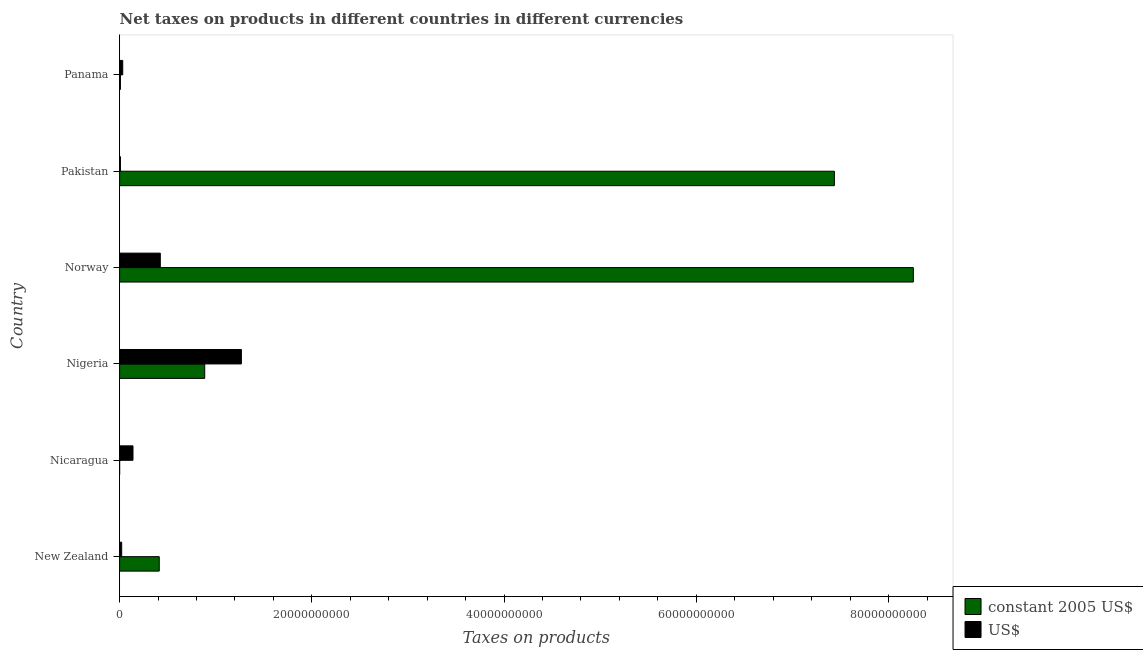Are the number of bars per tick equal to the number of legend labels?
Your response must be concise. Yes. What is the net taxes in us$ in Nicaragua?
Offer a very short reply. 1.39e+09. Across all countries, what is the maximum net taxes in us$?
Give a very brief answer. 1.27e+1. Across all countries, what is the minimum net taxes in us$?
Ensure brevity in your answer.  8.76e+07. In which country was the net taxes in us$ maximum?
Keep it short and to the point. Nigeria. In which country was the net taxes in us$ minimum?
Keep it short and to the point. Pakistan. What is the total net taxes in constant 2005 us$ in the graph?
Give a very brief answer. 1.70e+11. What is the difference between the net taxes in us$ in Nigeria and that in Panama?
Offer a terse response. 1.23e+1. What is the difference between the net taxes in us$ in Norway and the net taxes in constant 2005 us$ in Pakistan?
Provide a succinct answer. -7.01e+1. What is the average net taxes in us$ per country?
Offer a terse response. 3.16e+09. What is the difference between the net taxes in constant 2005 us$ and net taxes in us$ in Panama?
Ensure brevity in your answer.  -2.39e+08. What is the ratio of the net taxes in us$ in Nicaragua to that in Pakistan?
Make the answer very short. 15.9. Is the net taxes in constant 2005 us$ in Pakistan less than that in Panama?
Offer a terse response. No. What is the difference between the highest and the second highest net taxes in us$?
Your answer should be very brief. 8.44e+09. What is the difference between the highest and the lowest net taxes in constant 2005 us$?
Provide a short and direct response. 8.26e+1. In how many countries, is the net taxes in us$ greater than the average net taxes in us$ taken over all countries?
Keep it short and to the point. 2. What does the 1st bar from the top in Panama represents?
Your answer should be compact. US$. What does the 2nd bar from the bottom in New Zealand represents?
Your answer should be very brief. US$. What is the difference between two consecutive major ticks on the X-axis?
Provide a succinct answer. 2.00e+1. Are the values on the major ticks of X-axis written in scientific E-notation?
Provide a short and direct response. No. How many legend labels are there?
Give a very brief answer. 2. What is the title of the graph?
Give a very brief answer. Net taxes on products in different countries in different currencies. Does "State government" appear as one of the legend labels in the graph?
Offer a terse response. No. What is the label or title of the X-axis?
Your answer should be compact. Taxes on products. What is the Taxes on products of constant 2005 US$ in New Zealand?
Your response must be concise. 4.13e+09. What is the Taxes on products in US$ in New Zealand?
Offer a terse response. 2.17e+08. What is the Taxes on products in constant 2005 US$ in Nicaragua?
Ensure brevity in your answer.  5343.08. What is the Taxes on products of US$ in Nicaragua?
Provide a short and direct response. 1.39e+09. What is the Taxes on products of constant 2005 US$ in Nigeria?
Your response must be concise. 8.86e+09. What is the Taxes on products of US$ in Nigeria?
Your answer should be compact. 1.27e+1. What is the Taxes on products in constant 2005 US$ in Norway?
Your response must be concise. 8.26e+1. What is the Taxes on products in US$ in Norway?
Your answer should be compact. 4.24e+09. What is the Taxes on products of constant 2005 US$ in Pakistan?
Provide a succinct answer. 7.44e+1. What is the Taxes on products in US$ in Pakistan?
Your answer should be very brief. 8.76e+07. What is the Taxes on products of constant 2005 US$ in Panama?
Provide a short and direct response. 8.76e+07. What is the Taxes on products in US$ in Panama?
Your answer should be very brief. 3.27e+08. Across all countries, what is the maximum Taxes on products of constant 2005 US$?
Your answer should be compact. 8.26e+1. Across all countries, what is the maximum Taxes on products of US$?
Your answer should be compact. 1.27e+1. Across all countries, what is the minimum Taxes on products of constant 2005 US$?
Offer a very short reply. 5343.08. Across all countries, what is the minimum Taxes on products of US$?
Ensure brevity in your answer.  8.76e+07. What is the total Taxes on products of constant 2005 US$ in the graph?
Offer a terse response. 1.70e+11. What is the total Taxes on products of US$ in the graph?
Give a very brief answer. 1.89e+1. What is the difference between the Taxes on products of constant 2005 US$ in New Zealand and that in Nicaragua?
Give a very brief answer. 4.13e+09. What is the difference between the Taxes on products of US$ in New Zealand and that in Nicaragua?
Make the answer very short. -1.18e+09. What is the difference between the Taxes on products in constant 2005 US$ in New Zealand and that in Nigeria?
Offer a very short reply. -4.73e+09. What is the difference between the Taxes on products in US$ in New Zealand and that in Nigeria?
Make the answer very short. -1.25e+1. What is the difference between the Taxes on products of constant 2005 US$ in New Zealand and that in Norway?
Offer a terse response. -7.85e+1. What is the difference between the Taxes on products of US$ in New Zealand and that in Norway?
Give a very brief answer. -4.02e+09. What is the difference between the Taxes on products in constant 2005 US$ in New Zealand and that in Pakistan?
Your response must be concise. -7.02e+1. What is the difference between the Taxes on products of US$ in New Zealand and that in Pakistan?
Your answer should be very brief. 1.30e+08. What is the difference between the Taxes on products in constant 2005 US$ in New Zealand and that in Panama?
Give a very brief answer. 4.04e+09. What is the difference between the Taxes on products in US$ in New Zealand and that in Panama?
Keep it short and to the point. -1.09e+08. What is the difference between the Taxes on products of constant 2005 US$ in Nicaragua and that in Nigeria?
Provide a short and direct response. -8.86e+09. What is the difference between the Taxes on products of US$ in Nicaragua and that in Nigeria?
Your answer should be very brief. -1.13e+1. What is the difference between the Taxes on products of constant 2005 US$ in Nicaragua and that in Norway?
Ensure brevity in your answer.  -8.26e+1. What is the difference between the Taxes on products of US$ in Nicaragua and that in Norway?
Your answer should be compact. -2.84e+09. What is the difference between the Taxes on products in constant 2005 US$ in Nicaragua and that in Pakistan?
Offer a terse response. -7.44e+1. What is the difference between the Taxes on products of US$ in Nicaragua and that in Pakistan?
Offer a terse response. 1.31e+09. What is the difference between the Taxes on products in constant 2005 US$ in Nicaragua and that in Panama?
Your answer should be very brief. -8.76e+07. What is the difference between the Taxes on products in US$ in Nicaragua and that in Panama?
Give a very brief answer. 1.07e+09. What is the difference between the Taxes on products in constant 2005 US$ in Nigeria and that in Norway?
Offer a very short reply. -7.37e+1. What is the difference between the Taxes on products in US$ in Nigeria and that in Norway?
Keep it short and to the point. 8.44e+09. What is the difference between the Taxes on products in constant 2005 US$ in Nigeria and that in Pakistan?
Offer a terse response. -6.55e+1. What is the difference between the Taxes on products in US$ in Nigeria and that in Pakistan?
Ensure brevity in your answer.  1.26e+1. What is the difference between the Taxes on products in constant 2005 US$ in Nigeria and that in Panama?
Offer a terse response. 8.77e+09. What is the difference between the Taxes on products of US$ in Nigeria and that in Panama?
Offer a very short reply. 1.23e+1. What is the difference between the Taxes on products of constant 2005 US$ in Norway and that in Pakistan?
Provide a short and direct response. 8.21e+09. What is the difference between the Taxes on products in US$ in Norway and that in Pakistan?
Your response must be concise. 4.15e+09. What is the difference between the Taxes on products in constant 2005 US$ in Norway and that in Panama?
Your answer should be very brief. 8.25e+1. What is the difference between the Taxes on products in US$ in Norway and that in Panama?
Your answer should be compact. 3.91e+09. What is the difference between the Taxes on products of constant 2005 US$ in Pakistan and that in Panama?
Give a very brief answer. 7.43e+1. What is the difference between the Taxes on products in US$ in Pakistan and that in Panama?
Provide a short and direct response. -2.39e+08. What is the difference between the Taxes on products of constant 2005 US$ in New Zealand and the Taxes on products of US$ in Nicaragua?
Offer a very short reply. 2.73e+09. What is the difference between the Taxes on products in constant 2005 US$ in New Zealand and the Taxes on products in US$ in Nigeria?
Offer a terse response. -8.55e+09. What is the difference between the Taxes on products in constant 2005 US$ in New Zealand and the Taxes on products in US$ in Norway?
Provide a succinct answer. -1.11e+08. What is the difference between the Taxes on products of constant 2005 US$ in New Zealand and the Taxes on products of US$ in Pakistan?
Your answer should be compact. 4.04e+09. What is the difference between the Taxes on products of constant 2005 US$ in New Zealand and the Taxes on products of US$ in Panama?
Provide a short and direct response. 3.80e+09. What is the difference between the Taxes on products in constant 2005 US$ in Nicaragua and the Taxes on products in US$ in Nigeria?
Give a very brief answer. -1.27e+1. What is the difference between the Taxes on products in constant 2005 US$ in Nicaragua and the Taxes on products in US$ in Norway?
Provide a succinct answer. -4.24e+09. What is the difference between the Taxes on products of constant 2005 US$ in Nicaragua and the Taxes on products of US$ in Pakistan?
Your response must be concise. -8.76e+07. What is the difference between the Taxes on products in constant 2005 US$ in Nicaragua and the Taxes on products in US$ in Panama?
Your answer should be very brief. -3.27e+08. What is the difference between the Taxes on products of constant 2005 US$ in Nigeria and the Taxes on products of US$ in Norway?
Offer a terse response. 4.62e+09. What is the difference between the Taxes on products in constant 2005 US$ in Nigeria and the Taxes on products in US$ in Pakistan?
Offer a very short reply. 8.77e+09. What is the difference between the Taxes on products of constant 2005 US$ in Nigeria and the Taxes on products of US$ in Panama?
Ensure brevity in your answer.  8.53e+09. What is the difference between the Taxes on products of constant 2005 US$ in Norway and the Taxes on products of US$ in Pakistan?
Offer a terse response. 8.25e+1. What is the difference between the Taxes on products of constant 2005 US$ in Norway and the Taxes on products of US$ in Panama?
Your answer should be compact. 8.23e+1. What is the difference between the Taxes on products of constant 2005 US$ in Pakistan and the Taxes on products of US$ in Panama?
Ensure brevity in your answer.  7.40e+1. What is the average Taxes on products of constant 2005 US$ per country?
Your answer should be compact. 2.83e+1. What is the average Taxes on products of US$ per country?
Offer a very short reply. 3.16e+09. What is the difference between the Taxes on products in constant 2005 US$ and Taxes on products in US$ in New Zealand?
Ensure brevity in your answer.  3.91e+09. What is the difference between the Taxes on products in constant 2005 US$ and Taxes on products in US$ in Nicaragua?
Make the answer very short. -1.39e+09. What is the difference between the Taxes on products of constant 2005 US$ and Taxes on products of US$ in Nigeria?
Your answer should be compact. -3.82e+09. What is the difference between the Taxes on products in constant 2005 US$ and Taxes on products in US$ in Norway?
Provide a short and direct response. 7.83e+1. What is the difference between the Taxes on products in constant 2005 US$ and Taxes on products in US$ in Pakistan?
Provide a succinct answer. 7.43e+1. What is the difference between the Taxes on products in constant 2005 US$ and Taxes on products in US$ in Panama?
Give a very brief answer. -2.39e+08. What is the ratio of the Taxes on products of constant 2005 US$ in New Zealand to that in Nicaragua?
Your answer should be compact. 7.72e+05. What is the ratio of the Taxes on products in US$ in New Zealand to that in Nicaragua?
Offer a very short reply. 0.16. What is the ratio of the Taxes on products in constant 2005 US$ in New Zealand to that in Nigeria?
Ensure brevity in your answer.  0.47. What is the ratio of the Taxes on products of US$ in New Zealand to that in Nigeria?
Provide a short and direct response. 0.02. What is the ratio of the Taxes on products in constant 2005 US$ in New Zealand to that in Norway?
Your answer should be compact. 0.05. What is the ratio of the Taxes on products in US$ in New Zealand to that in Norway?
Make the answer very short. 0.05. What is the ratio of the Taxes on products of constant 2005 US$ in New Zealand to that in Pakistan?
Provide a succinct answer. 0.06. What is the ratio of the Taxes on products of US$ in New Zealand to that in Pakistan?
Offer a very short reply. 2.48. What is the ratio of the Taxes on products in constant 2005 US$ in New Zealand to that in Panama?
Provide a succinct answer. 47.09. What is the ratio of the Taxes on products of US$ in New Zealand to that in Panama?
Make the answer very short. 0.67. What is the ratio of the Taxes on products in constant 2005 US$ in Nicaragua to that in Nigeria?
Ensure brevity in your answer.  0. What is the ratio of the Taxes on products of US$ in Nicaragua to that in Nigeria?
Your answer should be very brief. 0.11. What is the ratio of the Taxes on products in US$ in Nicaragua to that in Norway?
Ensure brevity in your answer.  0.33. What is the ratio of the Taxes on products in constant 2005 US$ in Nicaragua to that in Pakistan?
Your response must be concise. 0. What is the ratio of the Taxes on products in US$ in Nicaragua to that in Pakistan?
Provide a short and direct response. 15.9. What is the ratio of the Taxes on products of constant 2005 US$ in Nicaragua to that in Panama?
Give a very brief answer. 0. What is the ratio of the Taxes on products of US$ in Nicaragua to that in Panama?
Make the answer very short. 4.27. What is the ratio of the Taxes on products in constant 2005 US$ in Nigeria to that in Norway?
Give a very brief answer. 0.11. What is the ratio of the Taxes on products of US$ in Nigeria to that in Norway?
Keep it short and to the point. 2.99. What is the ratio of the Taxes on products in constant 2005 US$ in Nigeria to that in Pakistan?
Your response must be concise. 0.12. What is the ratio of the Taxes on products in US$ in Nigeria to that in Pakistan?
Give a very brief answer. 144.65. What is the ratio of the Taxes on products in constant 2005 US$ in Nigeria to that in Panama?
Your answer should be very brief. 101.09. What is the ratio of the Taxes on products of US$ in Nigeria to that in Panama?
Your answer should be compact. 38.8. What is the ratio of the Taxes on products in constant 2005 US$ in Norway to that in Pakistan?
Keep it short and to the point. 1.11. What is the ratio of the Taxes on products in US$ in Norway to that in Pakistan?
Your answer should be very brief. 48.36. What is the ratio of the Taxes on products in constant 2005 US$ in Norway to that in Panama?
Ensure brevity in your answer.  942.68. What is the ratio of the Taxes on products in US$ in Norway to that in Panama?
Provide a short and direct response. 12.97. What is the ratio of the Taxes on products in constant 2005 US$ in Pakistan to that in Panama?
Provide a short and direct response. 848.9. What is the ratio of the Taxes on products of US$ in Pakistan to that in Panama?
Give a very brief answer. 0.27. What is the difference between the highest and the second highest Taxes on products of constant 2005 US$?
Ensure brevity in your answer.  8.21e+09. What is the difference between the highest and the second highest Taxes on products of US$?
Make the answer very short. 8.44e+09. What is the difference between the highest and the lowest Taxes on products of constant 2005 US$?
Offer a very short reply. 8.26e+1. What is the difference between the highest and the lowest Taxes on products in US$?
Your response must be concise. 1.26e+1. 